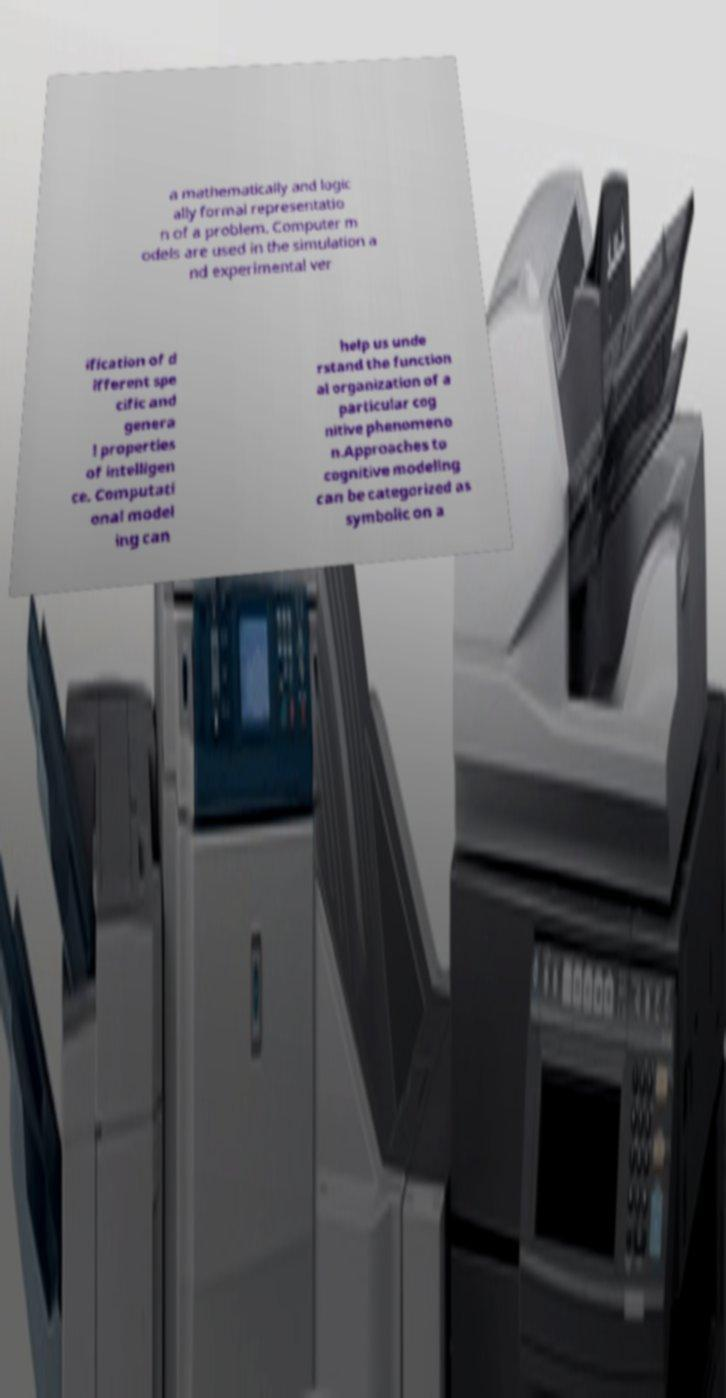There's text embedded in this image that I need extracted. Can you transcribe it verbatim? a mathematically and logic ally formal representatio n of a problem. Computer m odels are used in the simulation a nd experimental ver ification of d ifferent spe cific and genera l properties of intelligen ce. Computati onal model ing can help us unde rstand the function al organization of a particular cog nitive phenomeno n.Approaches to cognitive modeling can be categorized as symbolic on a 